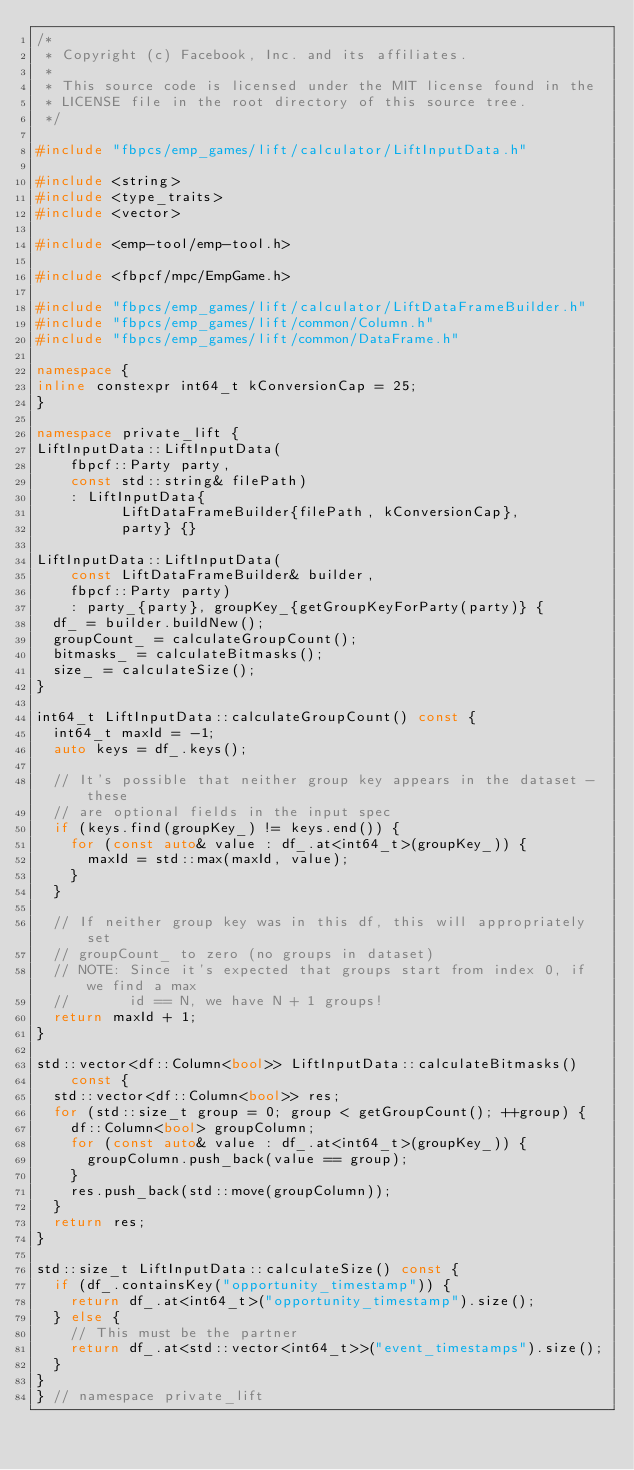Convert code to text. <code><loc_0><loc_0><loc_500><loc_500><_C++_>/*
 * Copyright (c) Facebook, Inc. and its affiliates.
 *
 * This source code is licensed under the MIT license found in the
 * LICENSE file in the root directory of this source tree.
 */

#include "fbpcs/emp_games/lift/calculator/LiftInputData.h"

#include <string>
#include <type_traits>
#include <vector>

#include <emp-tool/emp-tool.h>

#include <fbpcf/mpc/EmpGame.h>

#include "fbpcs/emp_games/lift/calculator/LiftDataFrameBuilder.h"
#include "fbpcs/emp_games/lift/common/Column.h"
#include "fbpcs/emp_games/lift/common/DataFrame.h"

namespace {
inline constexpr int64_t kConversionCap = 25;
}

namespace private_lift {
LiftInputData::LiftInputData(
    fbpcf::Party party,
    const std::string& filePath)
    : LiftInputData{
          LiftDataFrameBuilder{filePath, kConversionCap},
          party} {}

LiftInputData::LiftInputData(
    const LiftDataFrameBuilder& builder,
    fbpcf::Party party)
    : party_{party}, groupKey_{getGroupKeyForParty(party)} {
  df_ = builder.buildNew();
  groupCount_ = calculateGroupCount();
  bitmasks_ = calculateBitmasks();
  size_ = calculateSize();
}

int64_t LiftInputData::calculateGroupCount() const {
  int64_t maxId = -1;
  auto keys = df_.keys();

  // It's possible that neither group key appears in the dataset - these
  // are optional fields in the input spec
  if (keys.find(groupKey_) != keys.end()) {
    for (const auto& value : df_.at<int64_t>(groupKey_)) {
      maxId = std::max(maxId, value);
    }
  }

  // If neither group key was in this df, this will appropriately set
  // groupCount_ to zero (no groups in dataset)
  // NOTE: Since it's expected that groups start from index 0, if we find a max
  //       id == N, we have N + 1 groups!
  return maxId + 1;
}

std::vector<df::Column<bool>> LiftInputData::calculateBitmasks()
    const {
  std::vector<df::Column<bool>> res;
  for (std::size_t group = 0; group < getGroupCount(); ++group) {
    df::Column<bool> groupColumn;
    for (const auto& value : df_.at<int64_t>(groupKey_)) {
      groupColumn.push_back(value == group);
    }
    res.push_back(std::move(groupColumn));
  }
  return res;
}

std::size_t LiftInputData::calculateSize() const {
  if (df_.containsKey("opportunity_timestamp")) {
    return df_.at<int64_t>("opportunity_timestamp").size();
  } else {
    // This must be the partner
    return df_.at<std::vector<int64_t>>("event_timestamps").size();
  }
}
} // namespace private_lift
</code> 